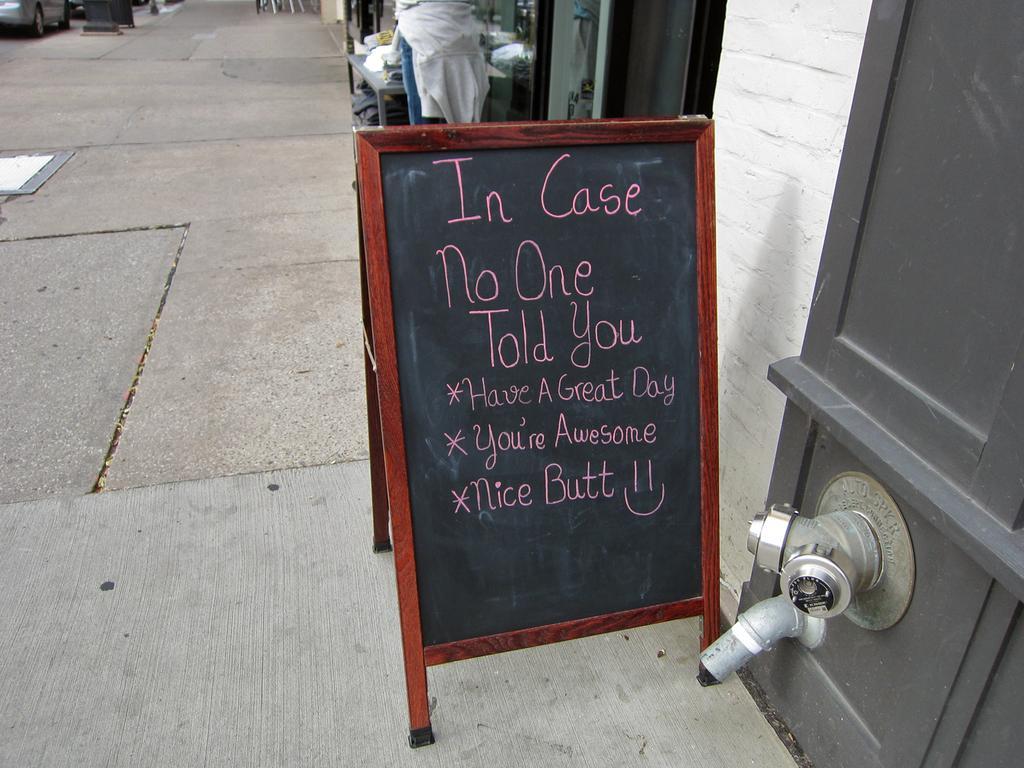In one or two sentences, can you explain what this image depicts? In this picture, we can see the ground and some objects on the ground like a board with some text on it, we can see table, and some objects on it, and some object on the right side of the picture, we can see a few vehicles. 